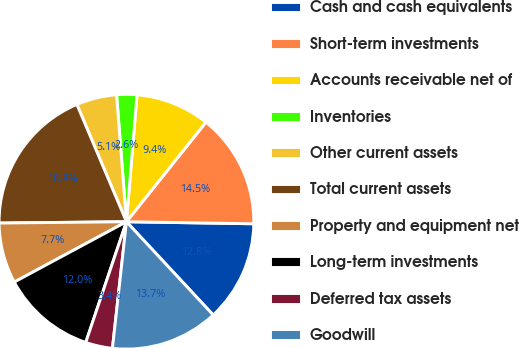<chart> <loc_0><loc_0><loc_500><loc_500><pie_chart><fcel>Cash and cash equivalents<fcel>Short-term investments<fcel>Accounts receivable net of<fcel>Inventories<fcel>Other current assets<fcel>Total current assets<fcel>Property and equipment net<fcel>Long-term investments<fcel>Deferred tax assets<fcel>Goodwill<nl><fcel>12.82%<fcel>14.53%<fcel>9.4%<fcel>2.56%<fcel>5.13%<fcel>18.8%<fcel>7.69%<fcel>11.97%<fcel>3.42%<fcel>13.68%<nl></chart> 